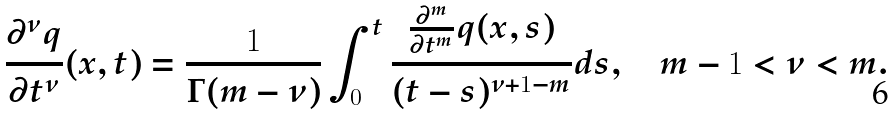Convert formula to latex. <formula><loc_0><loc_0><loc_500><loc_500>\frac { \partial ^ { \nu } q } { \partial t ^ { \nu } } ( x , t ) = \frac { 1 } { \Gamma ( m - \nu ) } \int _ { 0 } ^ { t } \frac { \frac { \partial ^ { m } } { \partial t ^ { m } } q ( x , s ) } { ( t - s ) ^ { \nu + 1 - m } } d s , \quad m - 1 < \nu < m .</formula> 